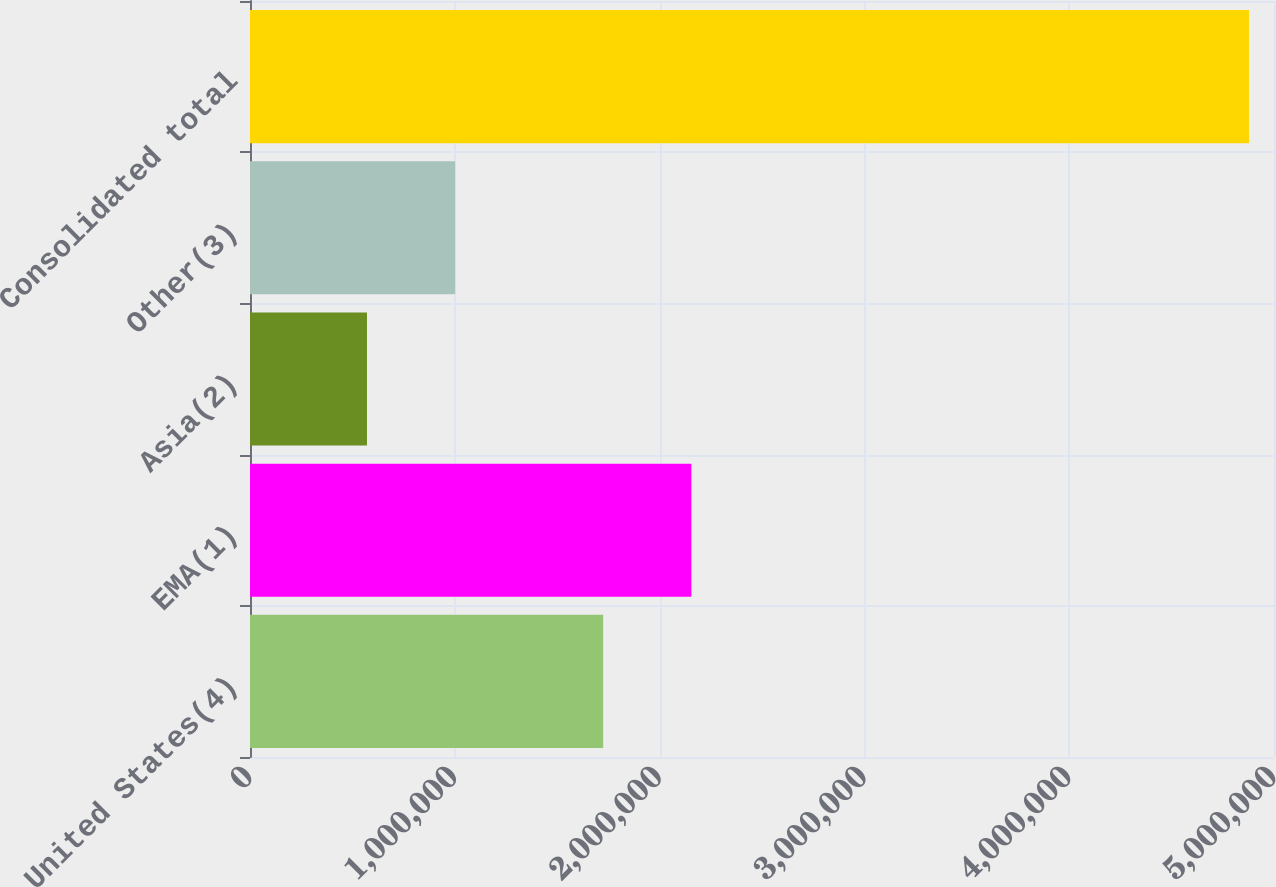Convert chart to OTSL. <chart><loc_0><loc_0><loc_500><loc_500><bar_chart><fcel>United States(4)<fcel>EMA(1)<fcel>Asia(2)<fcel>Other(3)<fcel>Consolidated total<nl><fcel>1.72439e+06<fcel>2.15506e+06<fcel>571195<fcel>1.00186e+06<fcel>4.87788e+06<nl></chart> 